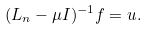<formula> <loc_0><loc_0><loc_500><loc_500>( L _ { n } - \mu I ) ^ { - 1 } f = u .</formula> 